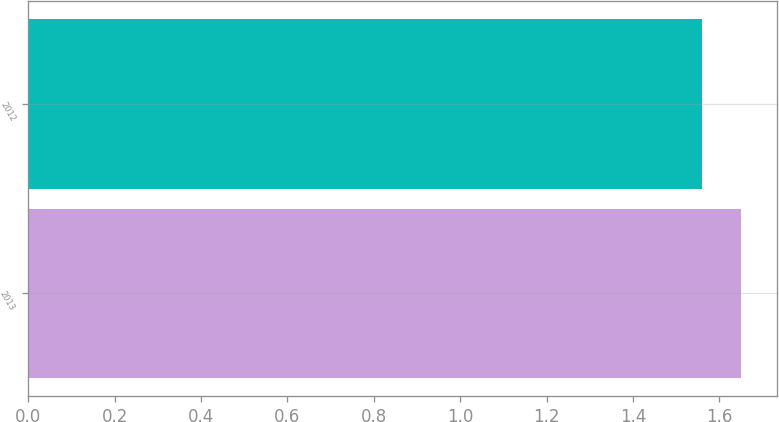Convert chart. <chart><loc_0><loc_0><loc_500><loc_500><bar_chart><fcel>2013<fcel>2012<nl><fcel>1.65<fcel>1.56<nl></chart> 